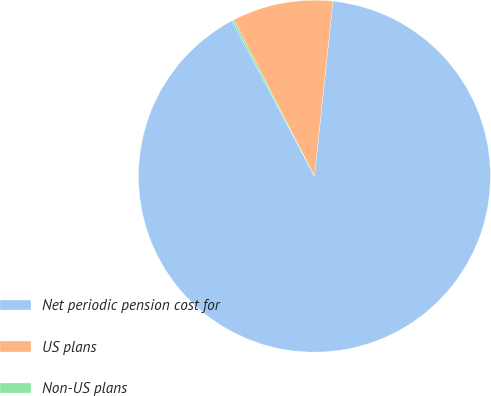<chart> <loc_0><loc_0><loc_500><loc_500><pie_chart><fcel>Net periodic pension cost for<fcel>US plans<fcel>Non-US plans<nl><fcel>90.56%<fcel>9.24%<fcel>0.2%<nl></chart> 